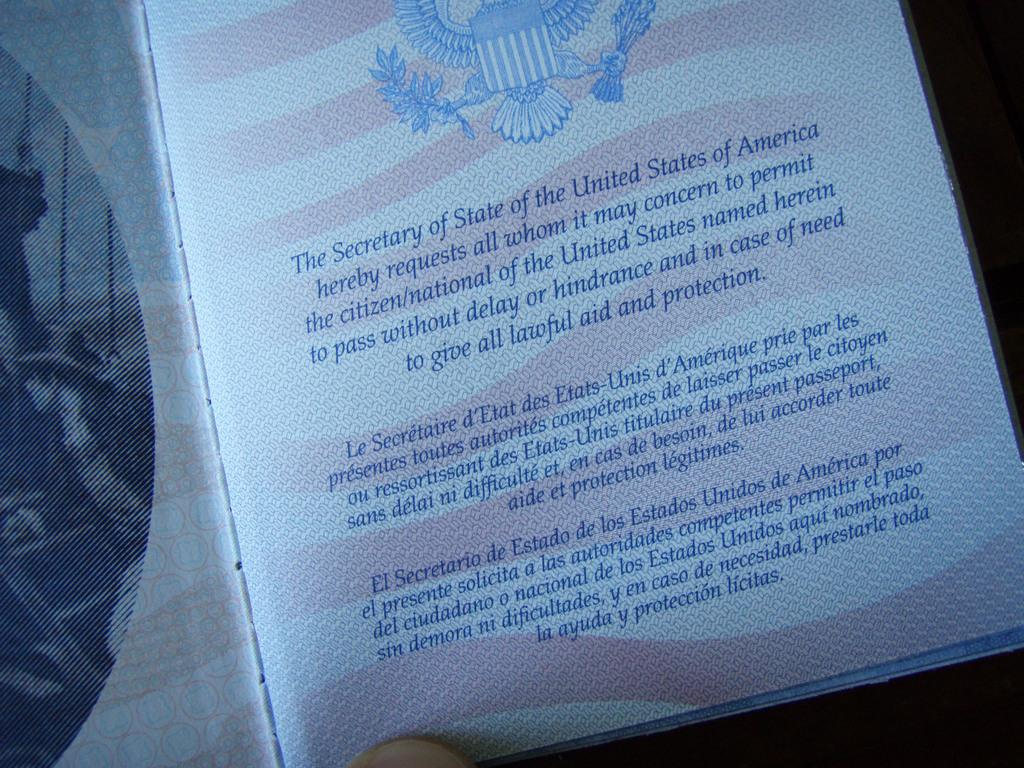Provide a one-sentence caption for the provided image. The inside portion of a United States passport. 